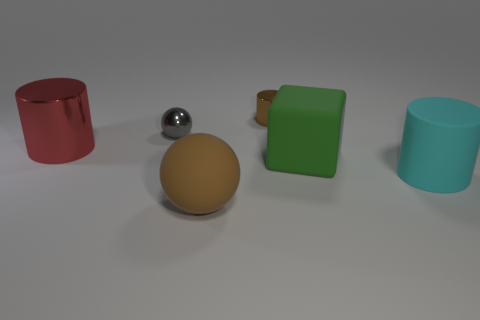Add 4 large purple cubes. How many objects exist? 10 Subtract all blocks. How many objects are left? 5 Add 1 cyan matte things. How many cyan matte things exist? 2 Subtract 0 cyan cubes. How many objects are left? 6 Subtract all purple matte blocks. Subtract all cylinders. How many objects are left? 3 Add 6 big green matte objects. How many big green matte objects are left? 7 